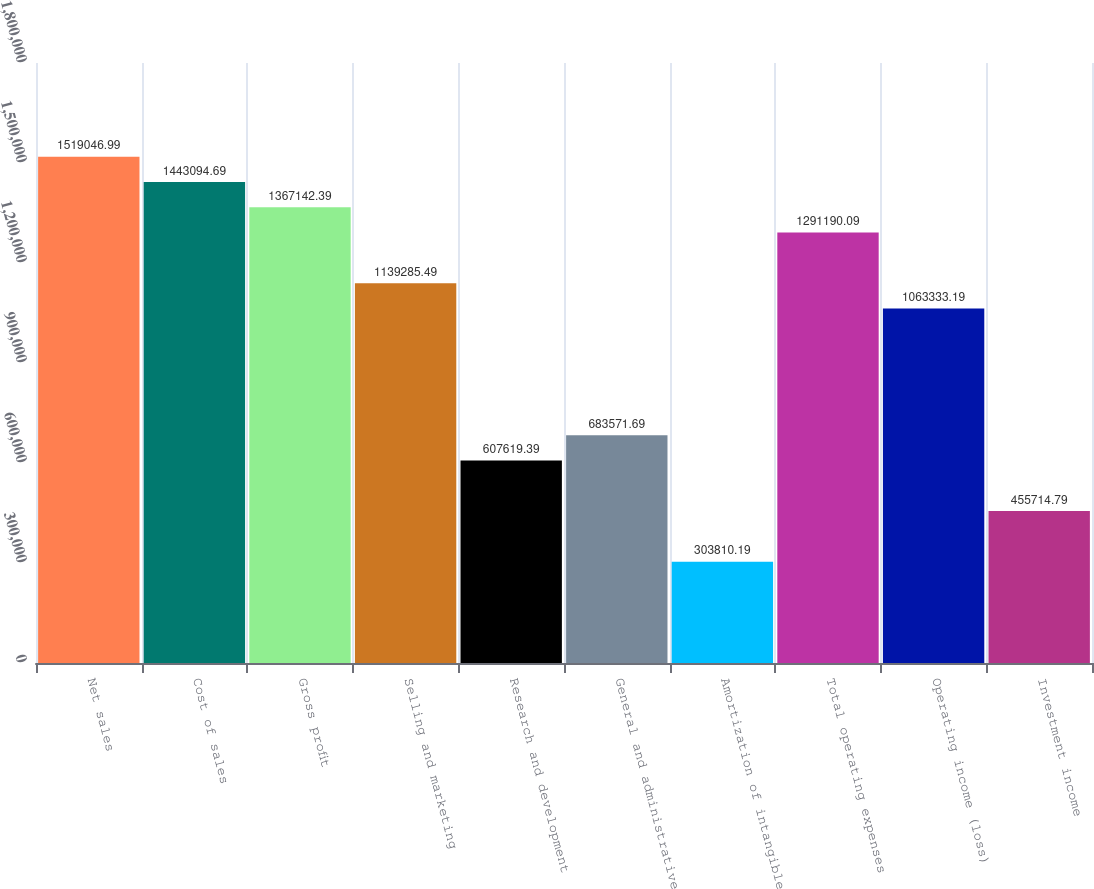Convert chart to OTSL. <chart><loc_0><loc_0><loc_500><loc_500><bar_chart><fcel>Net sales<fcel>Cost of sales<fcel>Gross profit<fcel>Selling and marketing<fcel>Research and development<fcel>General and administrative<fcel>Amortization of intangible<fcel>Total operating expenses<fcel>Operating income (loss)<fcel>Investment income<nl><fcel>1.51905e+06<fcel>1.44309e+06<fcel>1.36714e+06<fcel>1.13929e+06<fcel>607619<fcel>683572<fcel>303810<fcel>1.29119e+06<fcel>1.06333e+06<fcel>455715<nl></chart> 